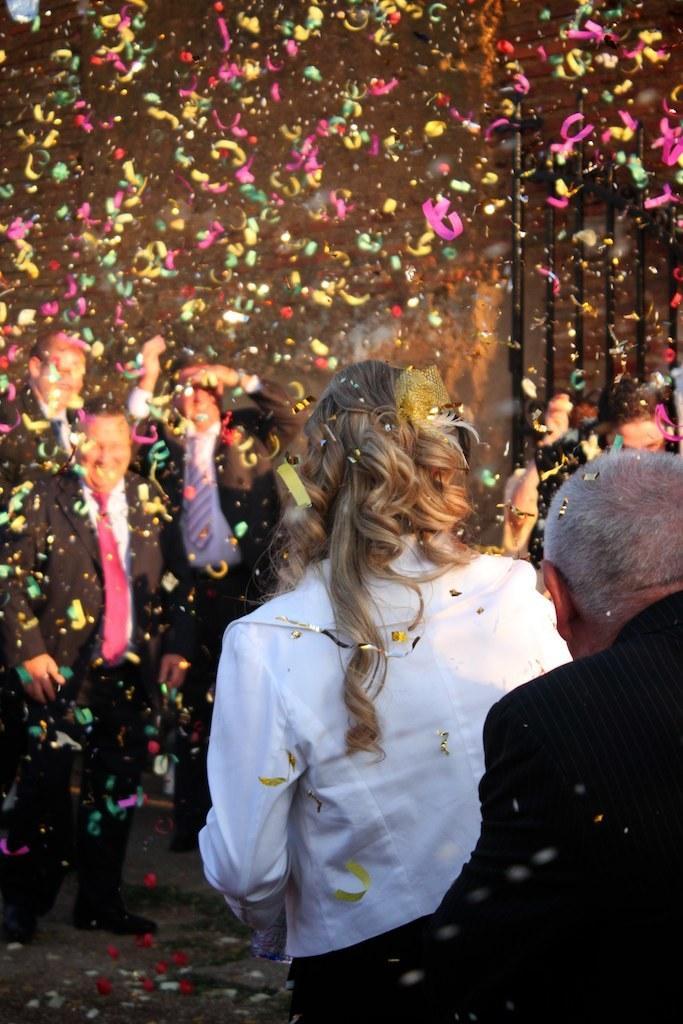In one or two sentences, can you explain what this image depicts? In this image I can see number of people are standing. I can also see number of colourful papers in air. In the background I can see few black colour poles. 